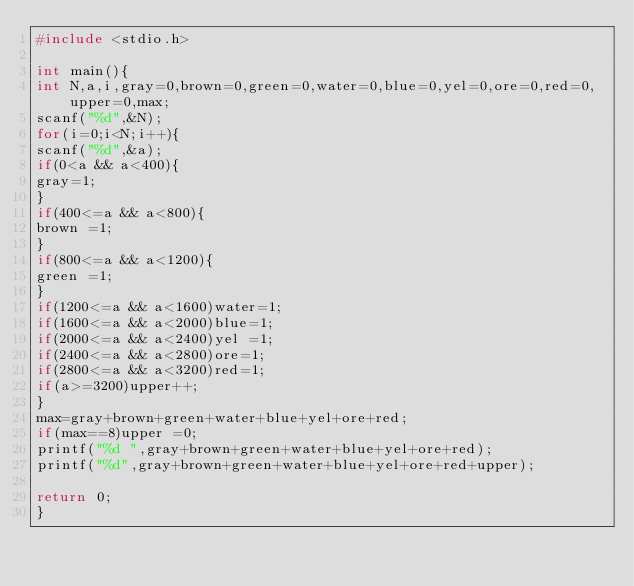<code> <loc_0><loc_0><loc_500><loc_500><_C_>#include <stdio.h>

int main(){
int N,a,i,gray=0,brown=0,green=0,water=0,blue=0,yel=0,ore=0,red=0,upper=0,max;
scanf("%d",&N);
for(i=0;i<N;i++){
scanf("%d",&a);
if(0<a && a<400){
gray=1;
}
if(400<=a && a<800){
brown =1;
}
if(800<=a && a<1200){
green =1;
}
if(1200<=a && a<1600)water=1;
if(1600<=a && a<2000)blue=1;
if(2000<=a && a<2400)yel =1;
if(2400<=a && a<2800)ore=1;
if(2800<=a && a<3200)red=1;
if(a>=3200)upper++;
}
max=gray+brown+green+water+blue+yel+ore+red;
if(max==8)upper =0;
printf("%d ",gray+brown+green+water+blue+yel+ore+red);
printf("%d",gray+brown+green+water+blue+yel+ore+red+upper);

return 0;
}</code> 